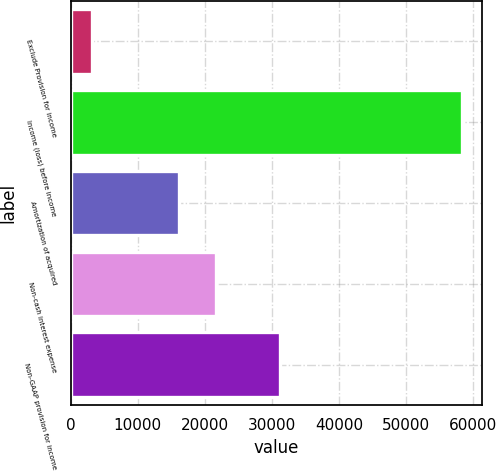Convert chart to OTSL. <chart><loc_0><loc_0><loc_500><loc_500><bar_chart><fcel>Exclude Provision for income<fcel>Income (loss) before income<fcel>Amortization of acquired<fcel>Non-cash interest expense<fcel>Non-GAAP provision for income<nl><fcel>3194<fcel>58365<fcel>16191<fcel>21708.1<fcel>31265<nl></chart> 